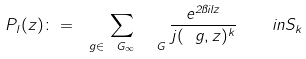<formula> <loc_0><loc_0><loc_500><loc_500>P _ { l } ( z ) \colon = \sum _ { \ g \in \ G _ { \infty } \ \ G } \frac { e ^ { 2 \pi i l z } } { j ( \ g , z ) ^ { k } } \quad i n S _ { k }</formula> 